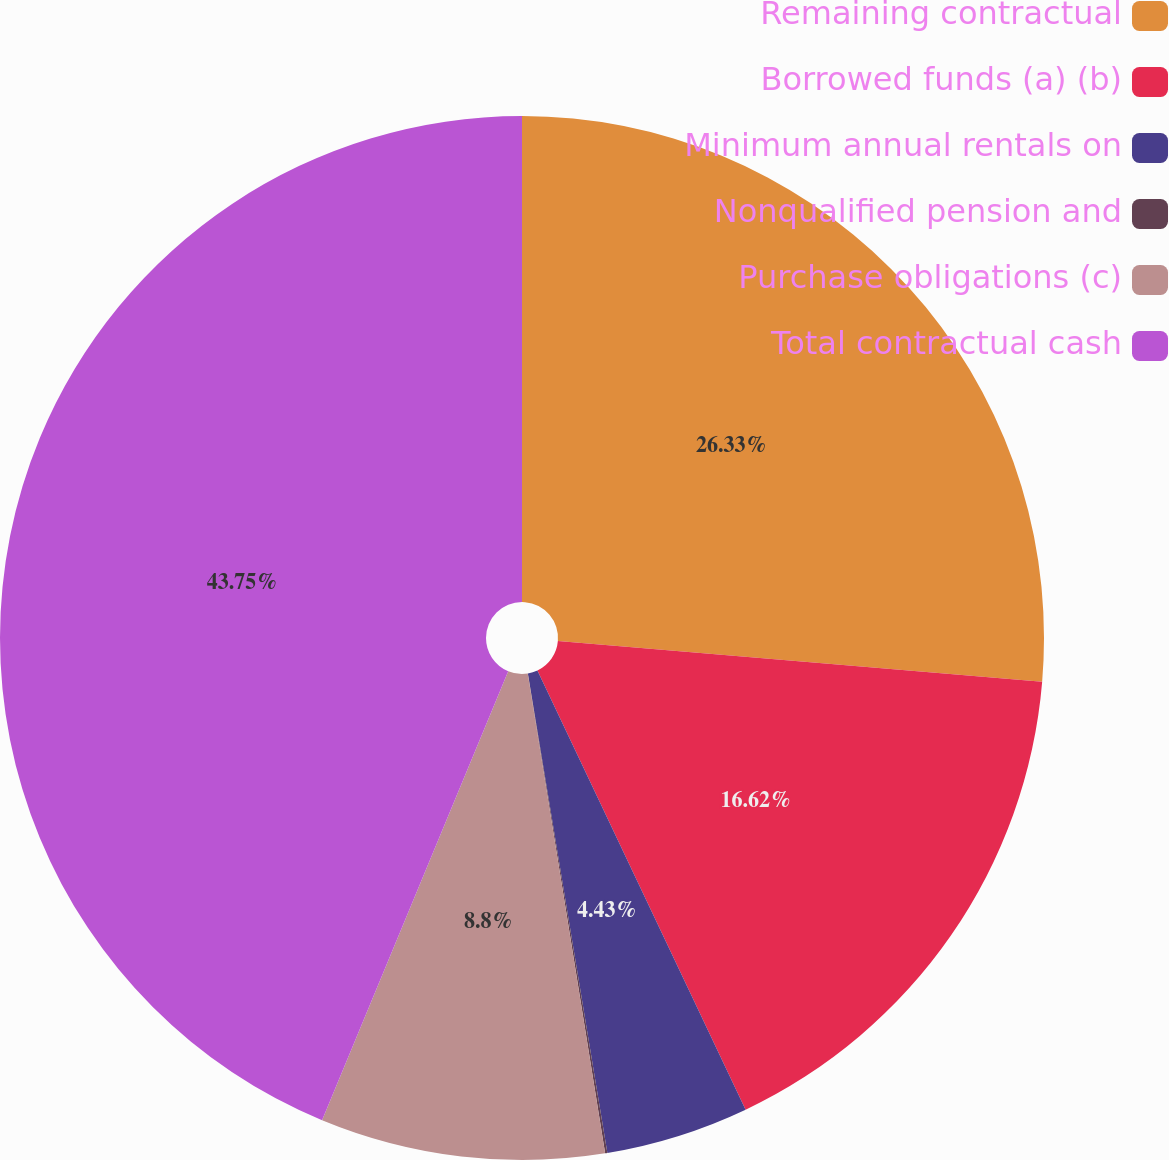<chart> <loc_0><loc_0><loc_500><loc_500><pie_chart><fcel>Remaining contractual<fcel>Borrowed funds (a) (b)<fcel>Minimum annual rentals on<fcel>Nonqualified pension and<fcel>Purchase obligations (c)<fcel>Total contractual cash<nl><fcel>26.33%<fcel>16.62%<fcel>4.43%<fcel>0.07%<fcel>8.8%<fcel>43.74%<nl></chart> 